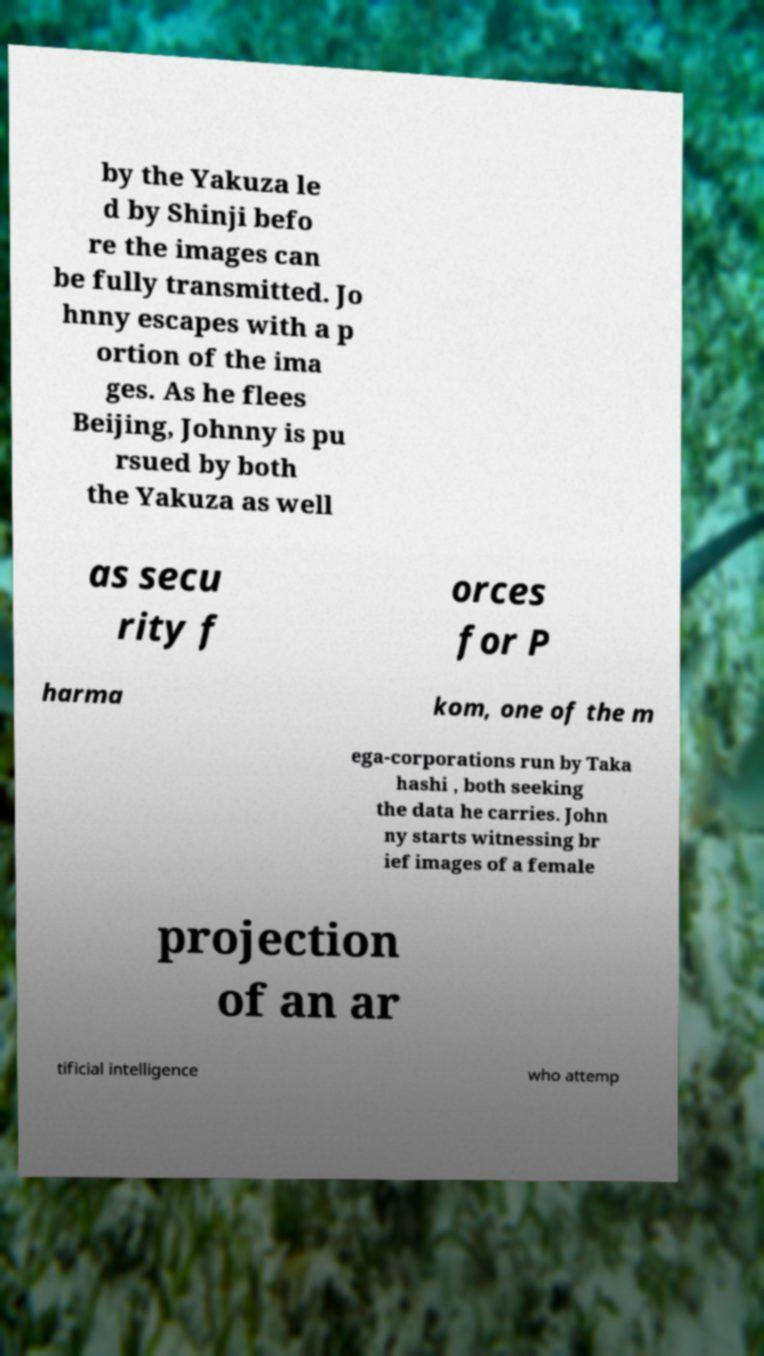Can you accurately transcribe the text from the provided image for me? by the Yakuza le d by Shinji befo re the images can be fully transmitted. Jo hnny escapes with a p ortion of the ima ges. As he flees Beijing, Johnny is pu rsued by both the Yakuza as well as secu rity f orces for P harma kom, one of the m ega-corporations run by Taka hashi , both seeking the data he carries. John ny starts witnessing br ief images of a female projection of an ar tificial intelligence who attemp 